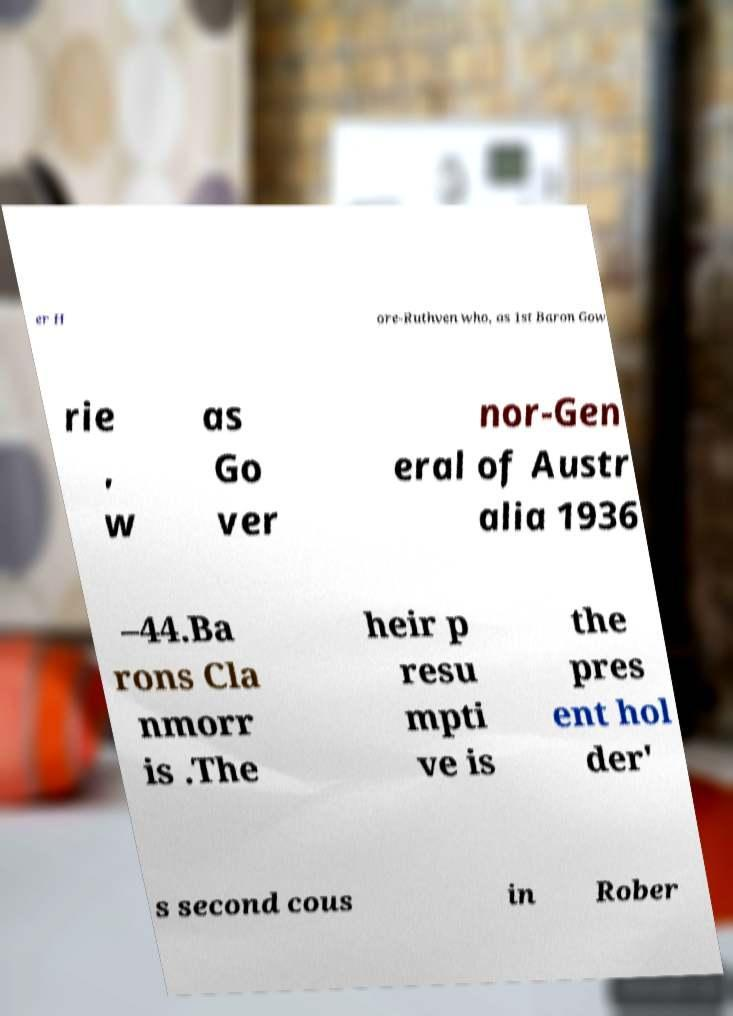Please read and relay the text visible in this image. What does it say? er H ore-Ruthven who, as 1st Baron Gow rie , w as Go ver nor-Gen eral of Austr alia 1936 –44.Ba rons Cla nmorr is .The heir p resu mpti ve is the pres ent hol der' s second cous in Rober 